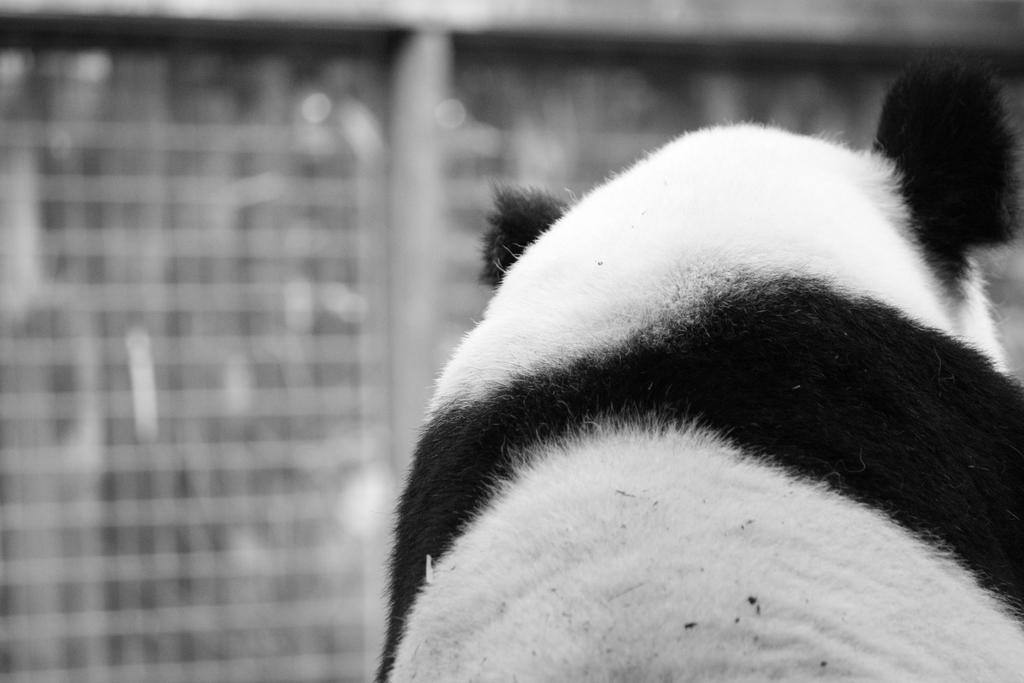What animal is the main subject of the image? There is a panda in the image. What colors can be seen on the panda? The panda is white and black in color. Can you describe the background of the image? The background of the image is blurred. How many horses are present in the image? There are no horses present in the image; it features a panda. What type of silk is being used to make the panda's clothing in the image? There is no clothing on the panda in the image, and therefore no silk can be observed. 